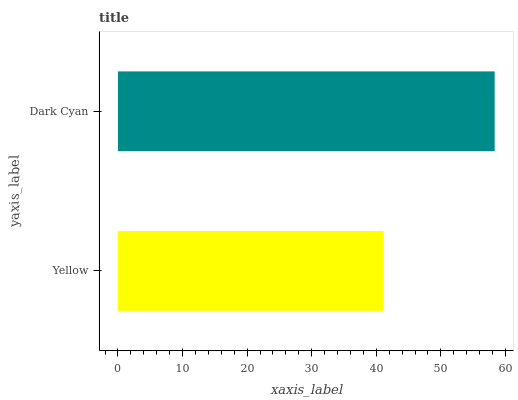Is Yellow the minimum?
Answer yes or no. Yes. Is Dark Cyan the maximum?
Answer yes or no. Yes. Is Dark Cyan the minimum?
Answer yes or no. No. Is Dark Cyan greater than Yellow?
Answer yes or no. Yes. Is Yellow less than Dark Cyan?
Answer yes or no. Yes. Is Yellow greater than Dark Cyan?
Answer yes or no. No. Is Dark Cyan less than Yellow?
Answer yes or no. No. Is Dark Cyan the high median?
Answer yes or no. Yes. Is Yellow the low median?
Answer yes or no. Yes. Is Yellow the high median?
Answer yes or no. No. Is Dark Cyan the low median?
Answer yes or no. No. 